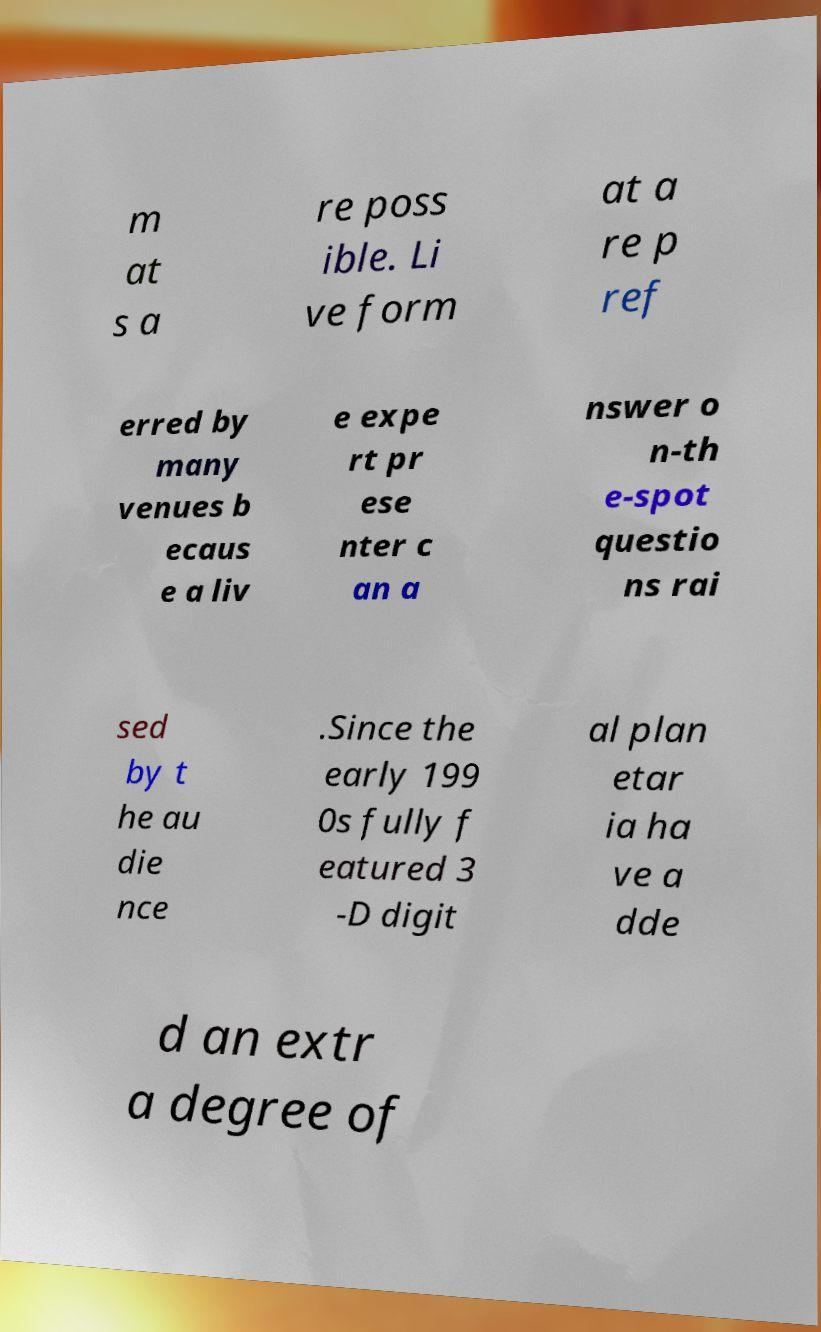What messages or text are displayed in this image? I need them in a readable, typed format. m at s a re poss ible. Li ve form at a re p ref erred by many venues b ecaus e a liv e expe rt pr ese nter c an a nswer o n-th e-spot questio ns rai sed by t he au die nce .Since the early 199 0s fully f eatured 3 -D digit al plan etar ia ha ve a dde d an extr a degree of 